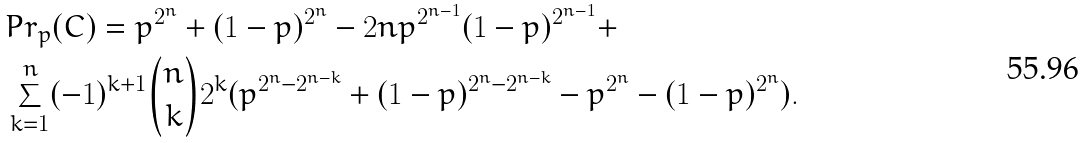<formula> <loc_0><loc_0><loc_500><loc_500>& P r _ { p } ( C ) = p ^ { 2 ^ { n } } + ( 1 - p ) ^ { 2 ^ { n } } - 2 n p ^ { 2 ^ { n - 1 } } ( 1 - p ) ^ { 2 ^ { n - 1 } } + \\ & \sum _ { k = 1 } ^ { n } ( - 1 ) ^ { k + 1 } \binom { n } { k } 2 ^ { k } ( p ^ { 2 ^ { n } - 2 ^ { n - k } } + ( 1 - p ) ^ { 2 ^ { n } - 2 ^ { n - k } } - p ^ { 2 ^ { n } } - ( 1 - p ) ^ { 2 ^ { n } } ) .</formula> 